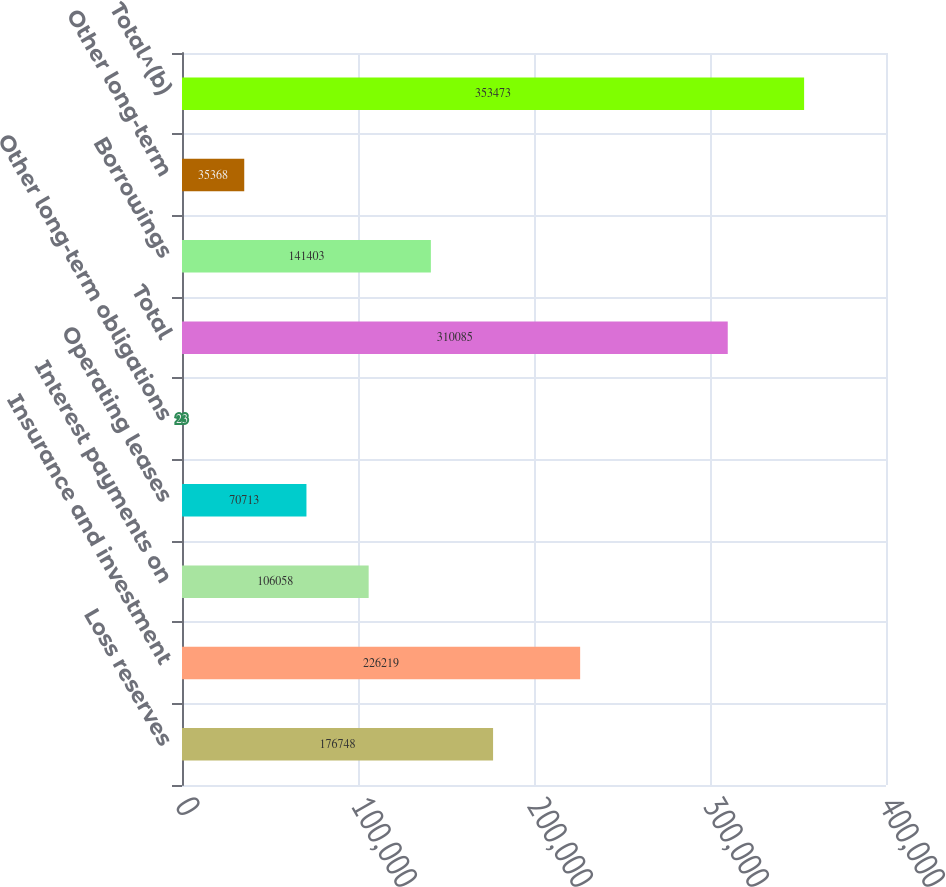Convert chart. <chart><loc_0><loc_0><loc_500><loc_500><bar_chart><fcel>Loss reserves<fcel>Insurance and investment<fcel>Interest payments on<fcel>Operating leases<fcel>Other long-term obligations<fcel>Total<fcel>Borrowings<fcel>Other long-term<fcel>Total^(b)<nl><fcel>176748<fcel>226219<fcel>106058<fcel>70713<fcel>23<fcel>310085<fcel>141403<fcel>35368<fcel>353473<nl></chart> 